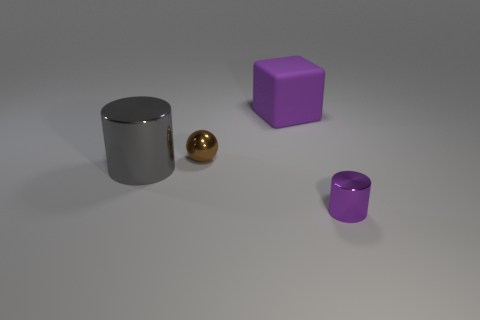Does the gray object have the same size as the object right of the big rubber cube?
Make the answer very short. No. Is there a small brown shiny thing that is in front of the purple object that is behind the purple object in front of the small brown object?
Offer a terse response. Yes. There is a small object on the right side of the small brown shiny ball; what is its material?
Your answer should be very brief. Metal. Do the metal ball and the gray shiny object have the same size?
Ensure brevity in your answer.  No. What is the color of the object that is both in front of the ball and to the right of the small metallic sphere?
Provide a short and direct response. Purple. What shape is the other large object that is made of the same material as the brown thing?
Your answer should be very brief. Cylinder. How many metal cylinders are both in front of the large cylinder and left of the purple metal object?
Offer a terse response. 0. Are there any big purple matte things behind the large rubber thing?
Your answer should be compact. No. There is a tiny object that is to the left of the small metal cylinder; is it the same shape as the purple thing that is left of the purple metal cylinder?
Make the answer very short. No. How many things are either brown spheres or shiny cylinders that are on the right side of the rubber block?
Keep it short and to the point. 2. 